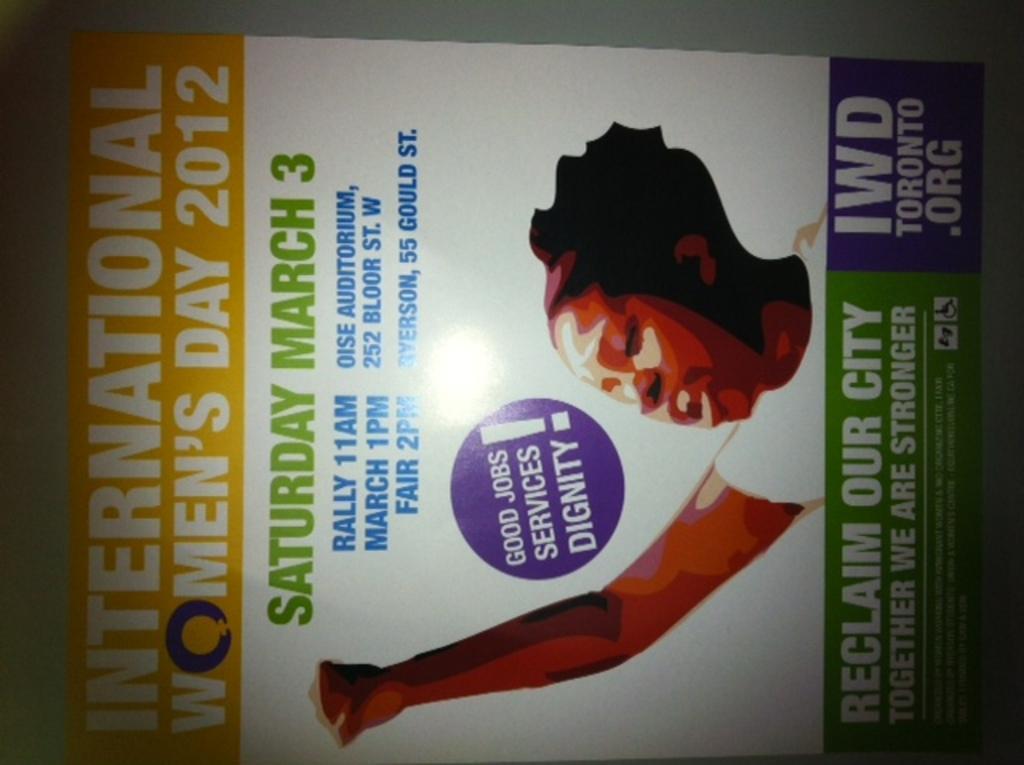Could you give a brief overview of what you see in this image? In this picture I can observe a cover page. There is a woman on this cover page. I can observe some text which is in white, green and blue colors. 